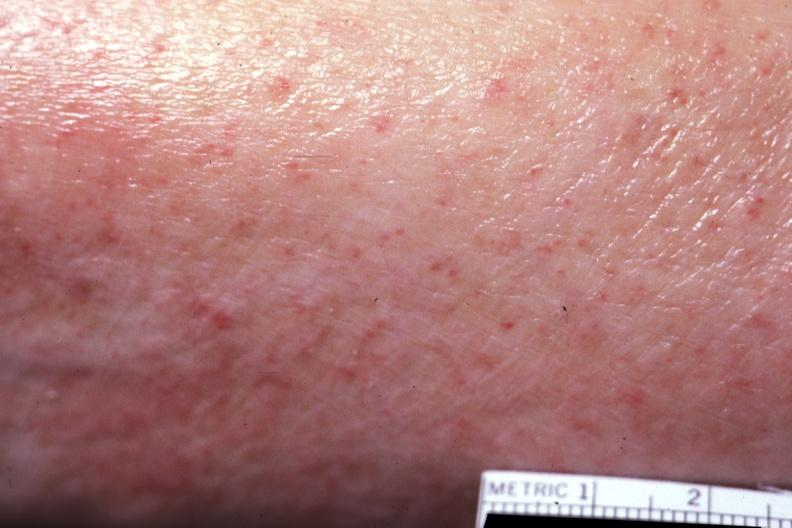s siamese twins present?
Answer the question using a single word or phrase. No 